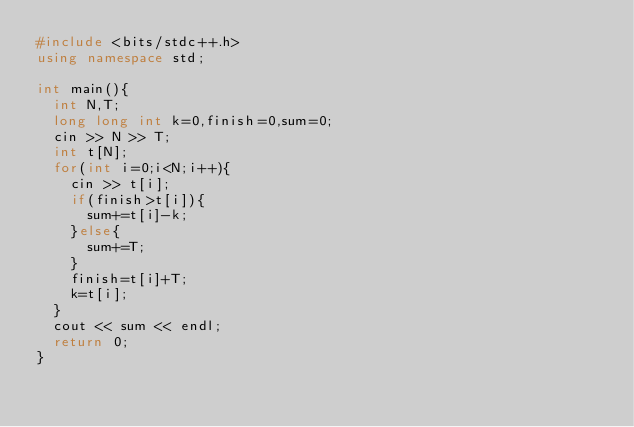<code> <loc_0><loc_0><loc_500><loc_500><_C++_>#include <bits/stdc++.h>
using namespace std;

int main(){
  int N,T;
  long long int k=0,finish=0,sum=0;
  cin >> N >> T;
  int t[N];
  for(int i=0;i<N;i++){
    cin >> t[i];
    if(finish>t[i]){
      sum+=t[i]-k;
    }else{
      sum+=T;
    }
    finish=t[i]+T;
    k=t[i];
  }
  cout << sum << endl;
  return 0;
}
</code> 